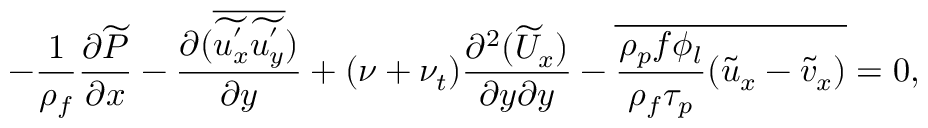Convert formula to latex. <formula><loc_0><loc_0><loc_500><loc_500>- \frac { 1 } { \rho _ { f } } \frac { \partial \widetilde { P } } { \partial x } - \frac { \partial ( \overline { { \widetilde { u _ { x } ^ { ^ { \prime } } } \widetilde { u _ { y } ^ { ^ { \prime } } } } } ) } { \partial y } + ( \nu + \nu _ { t } ) \frac { \partial ^ { 2 } ( \widetilde { U } _ { x } ) } { \partial y \partial y } - \overline { { \frac { \rho _ { p } f \phi _ { l } } { \rho _ { f } \tau _ { p } } ( \widetilde { u } _ { x } - \widetilde { v } _ { x } ) } } = 0 ,</formula> 